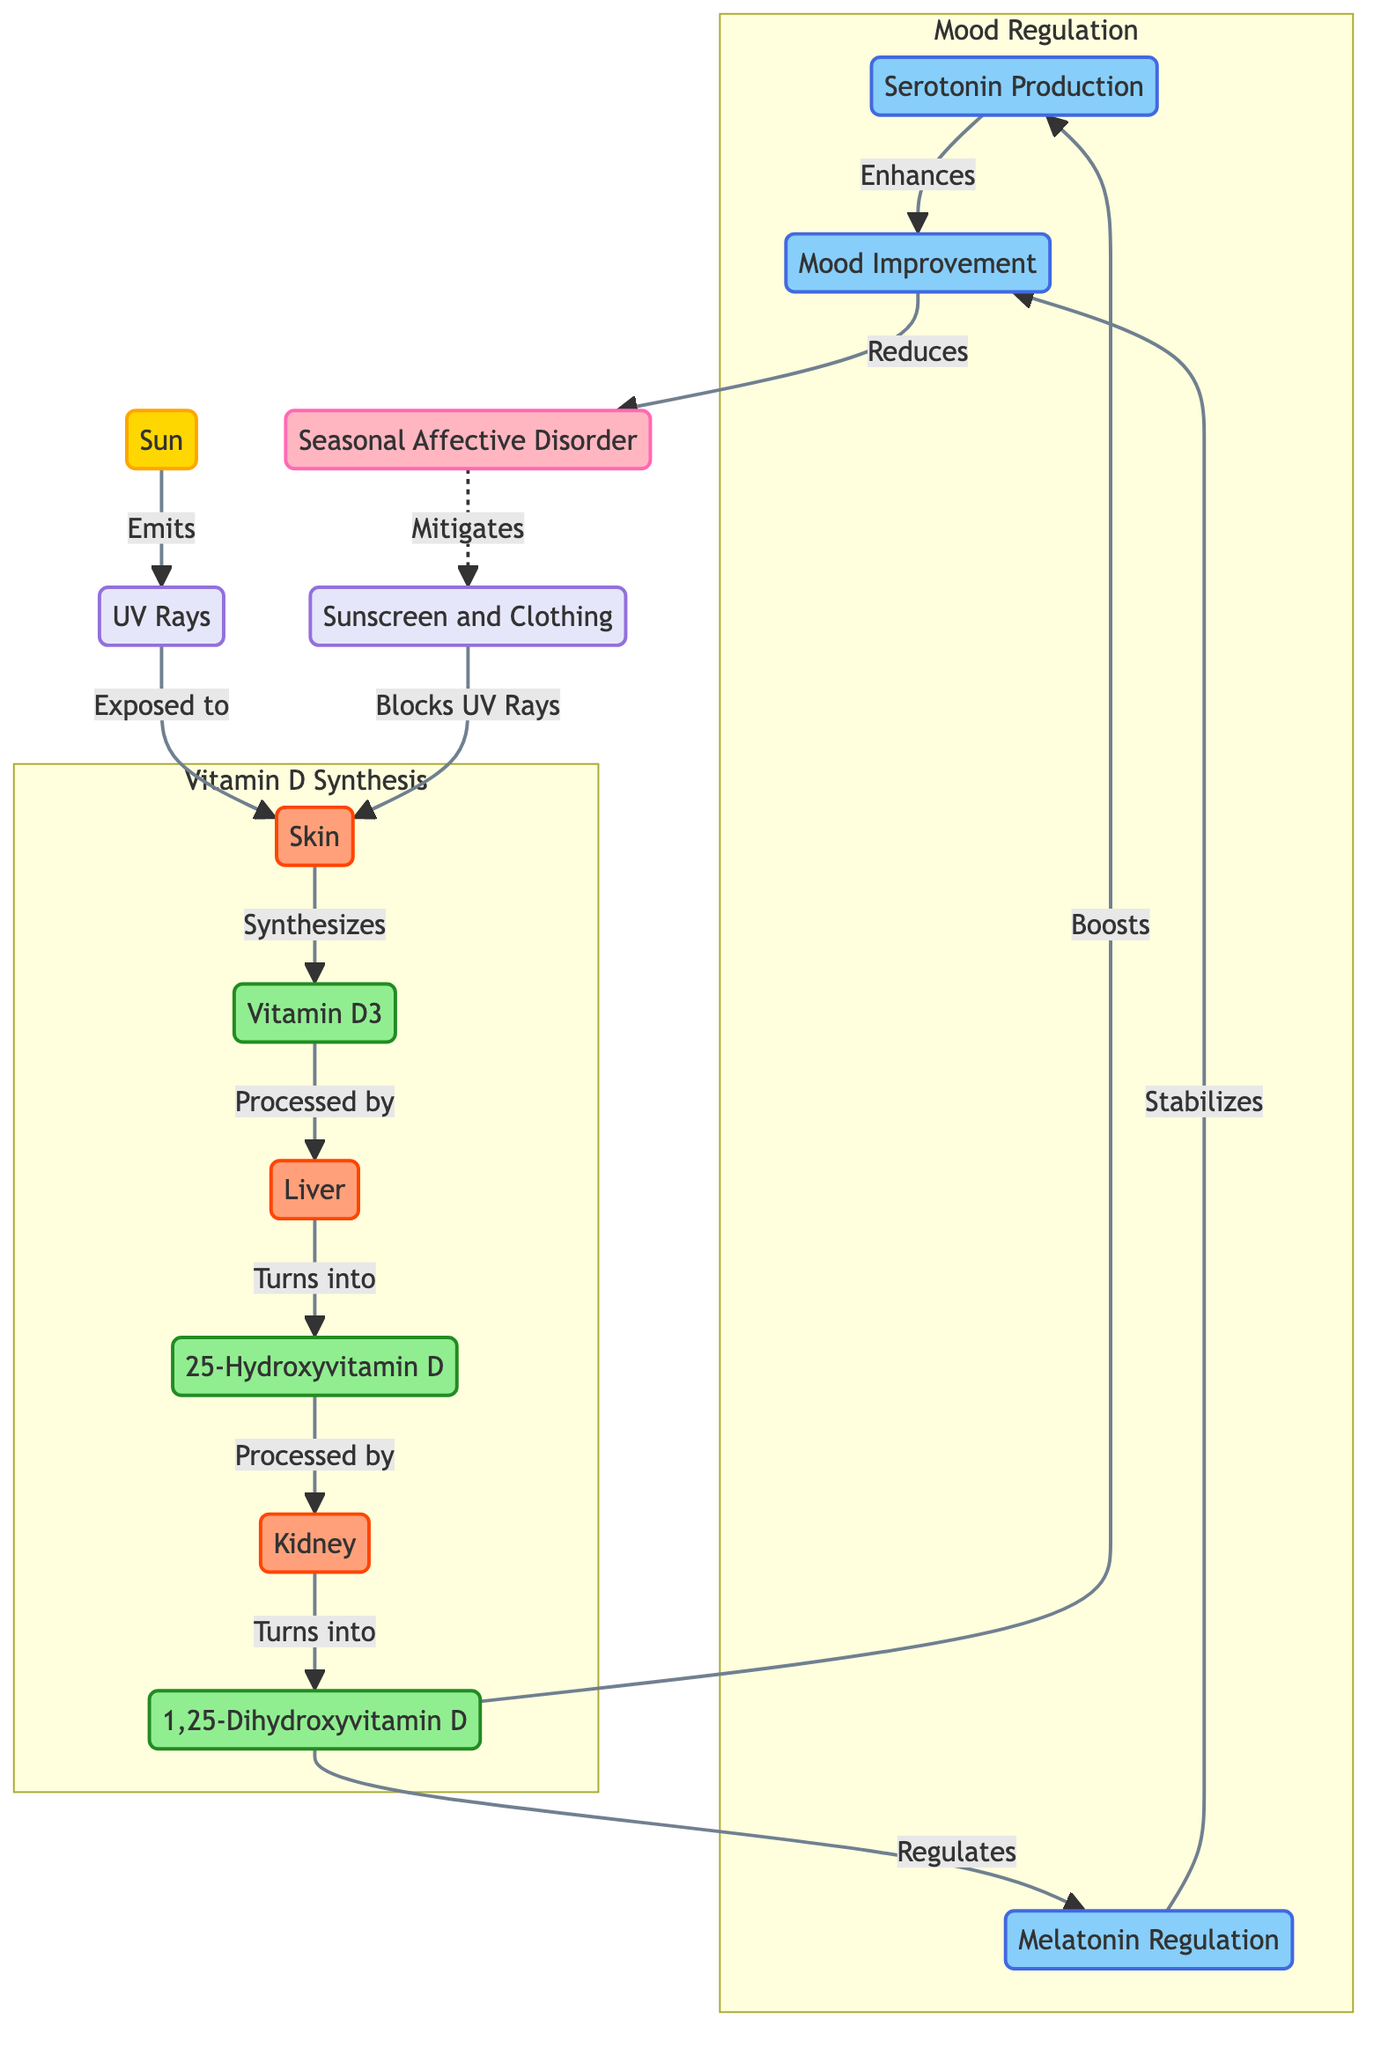What triggers the synthesis of Vitamin D3 in the skin? The diagram shows that UV rays are emitted from the sun and, when exposed to the skin, they trigger the synthesis of Vitamin D3.
Answer: UV Rays What is the first step in the Vitamin D synthesis process? According to the diagram, the first step in the Vitamin D synthesis process is the exposure of skin to UV rays.
Answer: Exposed to How many organs are involved in the conversion of Vitamin D3? The diagram describes the process involving three organs: the skin, liver, and kidney, making a total of three organs involved in the conversion.
Answer: 3 What is the final product of the Vitamin D synthesis process? The diagram indicates that the final product of the Vitamin D synthesis process is 1,25-Dihydroxyvitamin D.
Answer: 1,25-Dihydroxyvitamin D How does dihydroxyvitamin D affect serotonin production? From the diagram, dihydroxyvitamin D boosts serotonin production, indicating a positive effect on mood enhancement.
Answer: Boosts What role does melatonin play in mood stabilization? The diagram shows that melatonin regulates mood, which suggests it helps stabilize mood over time.
Answer: Stabilizes Which factor mitigates the risk of Seasonal Affective Disorder? The diagram illustrates that an enhanced mood, resultant from biochemical processes, reduces the risk of Seasonal Affective Disorder.
Answer: Reduces How does sunscreen affect UV rays in relation to Vitamin D synthesis? The diagram indicates that sunscreen blocks UV rays from reaching the skin, which prevents the synthesis of Vitamin D3.
Answer: Blocks UV Rays What connects dihydroxyvitamin D to mood improvement? The diagram highlights that dihydroxyvitamin D boosts serotonin, which enhances mood, establishing a connection between them.
Answer: Boosts 